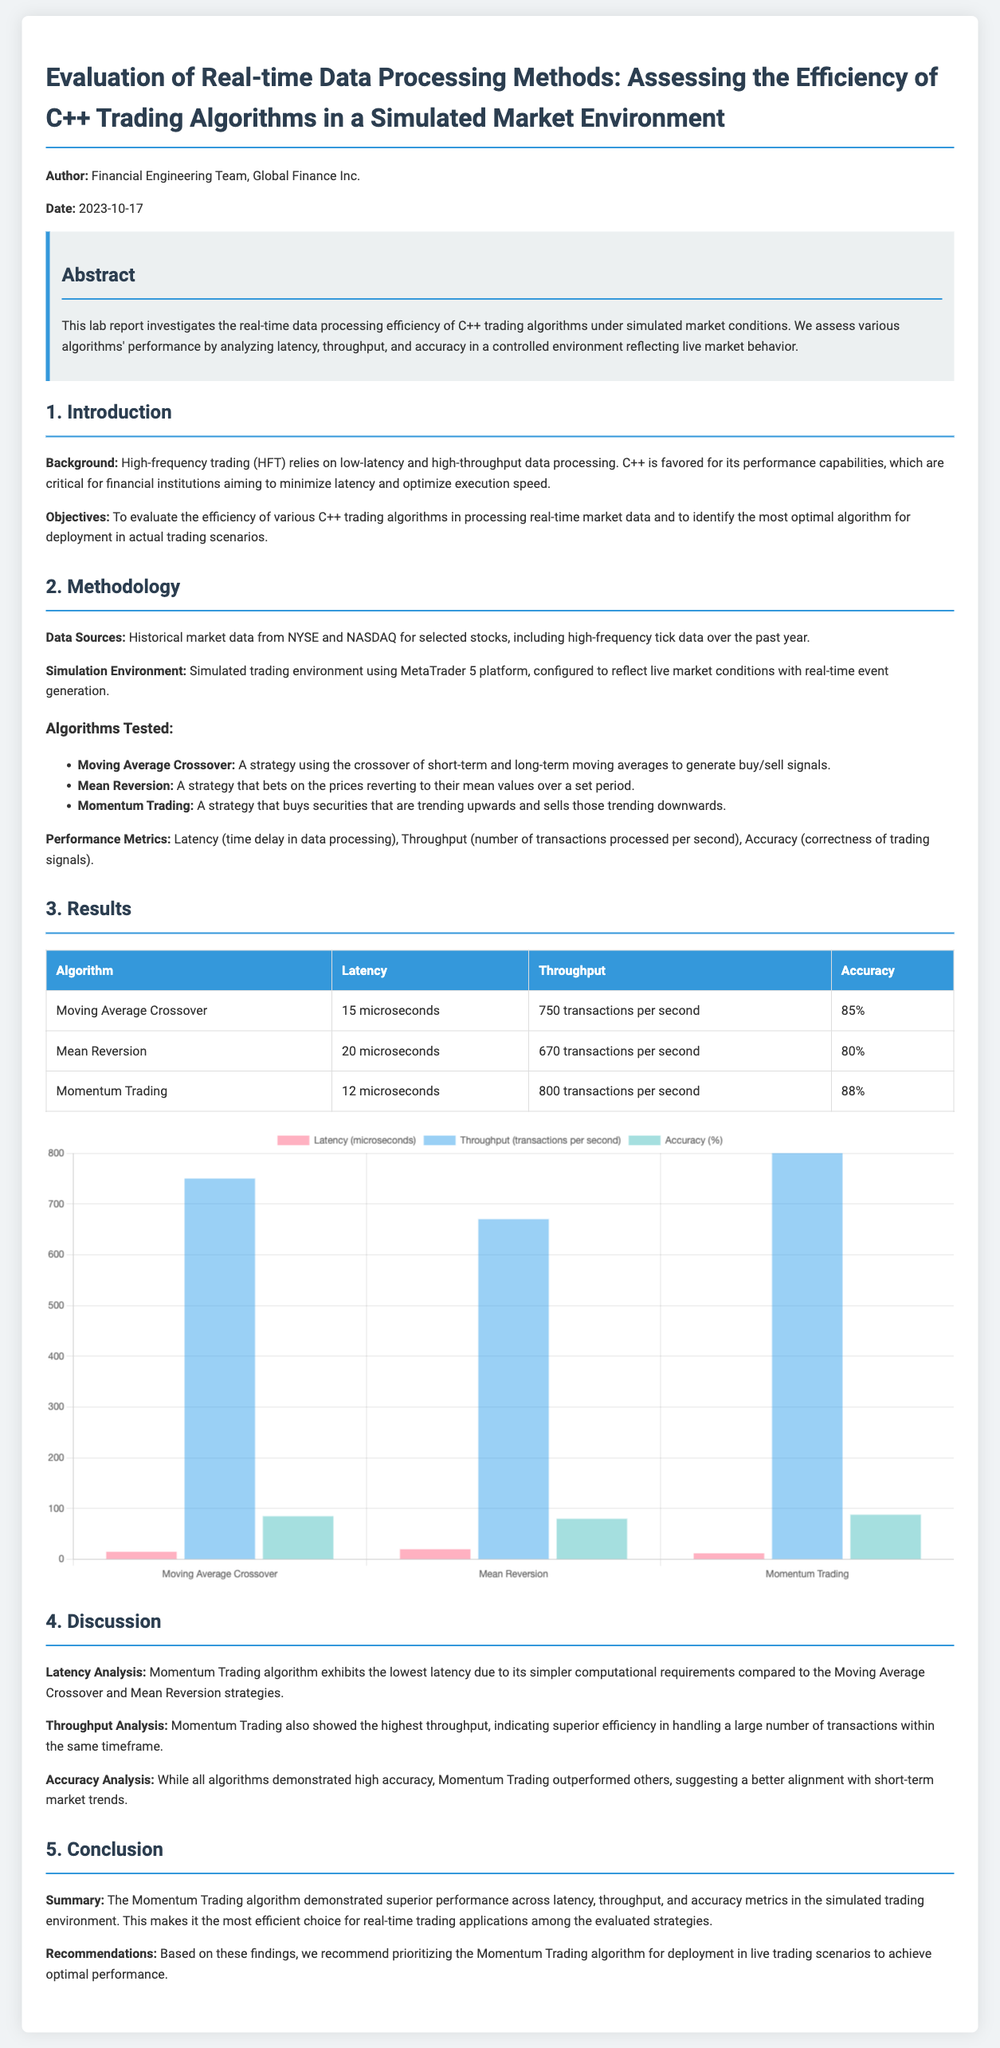What is the title of the report? The title of the report is stated at the top of the document, summarizing its focus.
Answer: Evaluation of Real-time Data Processing Methods: Assessing the Efficiency of C++ Trading Algorithms in a Simulated Market Environment What date was the report published? The publication date is mentioned in the introductory section of the document.
Answer: 2023-10-17 Which algorithm had the lowest latency? Latency comparisons are made in the results section, detailing the performance of each algorithm.
Answer: Momentum Trading How many transactions per second could the Moving Average Crossover process? The throughput for the Moving Average Crossover is provided in a table summarizing performance metrics.
Answer: 750 transactions per second What performance metric was measured as 88%? The accuracy for each algorithm is listed in the results table, indicating their performance.
Answer: Accuracy Which algorithm is recommended for deployment in live trading scenarios? The recommendation is found in the conclusion section, summarizing the findings of the study.
Answer: Momentum Trading What were the data sources for the simulation? The methodology section outlines the origins of the data used in the report.
Answer: Historical market data from NYSE and NASDAQ What was the throughput of the Mean Reversion algorithm? This information can be found in the performance metrics table comparing all algorithms.
Answer: 670 transactions per second What is the main objective of the report? The report outlines its aim in the introduction section, which highlights its focus on algorithm efficiency.
Answer: To evaluate the efficiency of various C++ trading algorithms 